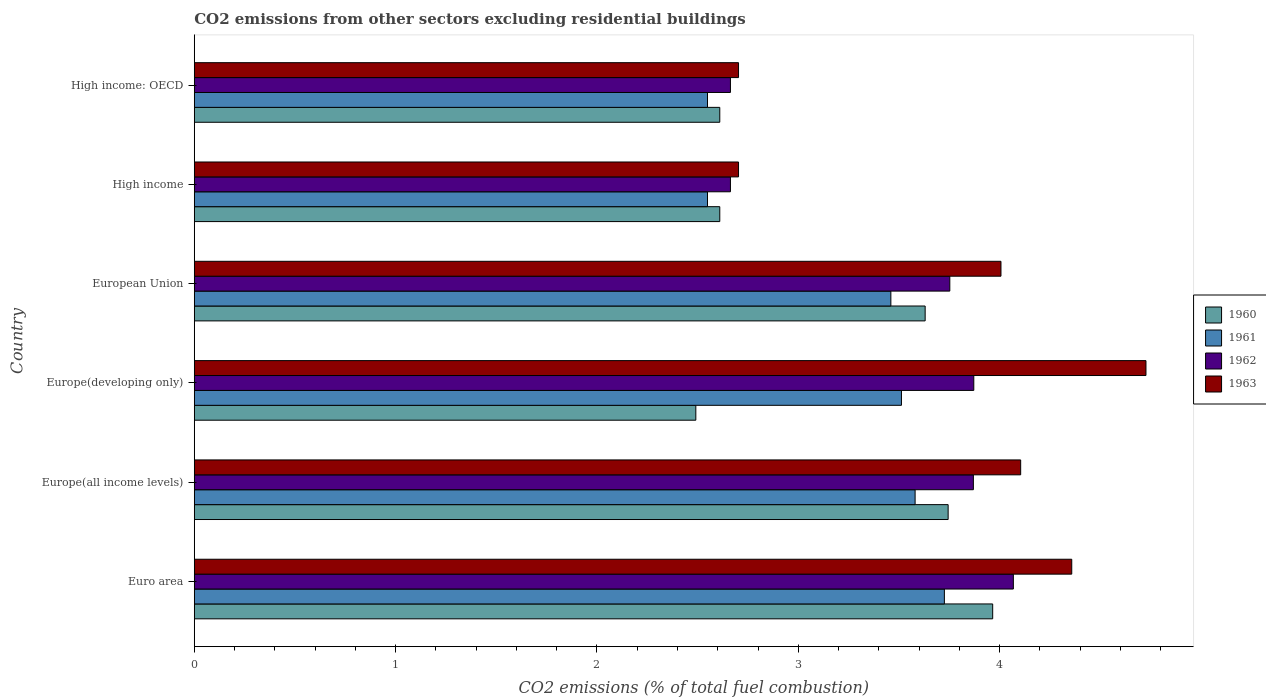How many different coloured bars are there?
Provide a succinct answer. 4. Are the number of bars on each tick of the Y-axis equal?
Keep it short and to the point. Yes. What is the total CO2 emitted in 1960 in Euro area?
Your answer should be very brief. 3.97. Across all countries, what is the maximum total CO2 emitted in 1962?
Make the answer very short. 4.07. Across all countries, what is the minimum total CO2 emitted in 1962?
Provide a short and direct response. 2.66. In which country was the total CO2 emitted in 1962 maximum?
Provide a short and direct response. Euro area. In which country was the total CO2 emitted in 1963 minimum?
Make the answer very short. High income. What is the total total CO2 emitted in 1962 in the graph?
Your answer should be compact. 20.89. What is the difference between the total CO2 emitted in 1962 in Europe(developing only) and that in High income: OECD?
Make the answer very short. 1.21. What is the difference between the total CO2 emitted in 1963 in Euro area and the total CO2 emitted in 1961 in Europe(developing only)?
Ensure brevity in your answer.  0.85. What is the average total CO2 emitted in 1962 per country?
Give a very brief answer. 3.48. What is the difference between the total CO2 emitted in 1960 and total CO2 emitted in 1961 in Europe(developing only)?
Provide a succinct answer. -1.02. In how many countries, is the total CO2 emitted in 1960 greater than 1.4 ?
Your answer should be very brief. 6. What is the ratio of the total CO2 emitted in 1962 in Europe(developing only) to that in High income: OECD?
Ensure brevity in your answer.  1.45. Is the difference between the total CO2 emitted in 1960 in Europe(all income levels) and High income: OECD greater than the difference between the total CO2 emitted in 1961 in Europe(all income levels) and High income: OECD?
Give a very brief answer. Yes. What is the difference between the highest and the second highest total CO2 emitted in 1961?
Ensure brevity in your answer.  0.15. What is the difference between the highest and the lowest total CO2 emitted in 1962?
Keep it short and to the point. 1.41. In how many countries, is the total CO2 emitted in 1962 greater than the average total CO2 emitted in 1962 taken over all countries?
Your answer should be compact. 4. Is the sum of the total CO2 emitted in 1963 in European Union and High income: OECD greater than the maximum total CO2 emitted in 1961 across all countries?
Your response must be concise. Yes. How many countries are there in the graph?
Your answer should be very brief. 6. What is the difference between two consecutive major ticks on the X-axis?
Provide a short and direct response. 1. How many legend labels are there?
Your answer should be very brief. 4. What is the title of the graph?
Ensure brevity in your answer.  CO2 emissions from other sectors excluding residential buildings. Does "1972" appear as one of the legend labels in the graph?
Make the answer very short. No. What is the label or title of the X-axis?
Your response must be concise. CO2 emissions (% of total fuel combustion). What is the CO2 emissions (% of total fuel combustion) in 1960 in Euro area?
Give a very brief answer. 3.97. What is the CO2 emissions (% of total fuel combustion) of 1961 in Euro area?
Your response must be concise. 3.73. What is the CO2 emissions (% of total fuel combustion) in 1962 in Euro area?
Your answer should be compact. 4.07. What is the CO2 emissions (% of total fuel combustion) in 1963 in Euro area?
Your response must be concise. 4.36. What is the CO2 emissions (% of total fuel combustion) of 1960 in Europe(all income levels)?
Provide a short and direct response. 3.74. What is the CO2 emissions (% of total fuel combustion) of 1961 in Europe(all income levels)?
Provide a short and direct response. 3.58. What is the CO2 emissions (% of total fuel combustion) of 1962 in Europe(all income levels)?
Give a very brief answer. 3.87. What is the CO2 emissions (% of total fuel combustion) in 1963 in Europe(all income levels)?
Provide a short and direct response. 4.1. What is the CO2 emissions (% of total fuel combustion) in 1960 in Europe(developing only)?
Your answer should be very brief. 2.49. What is the CO2 emissions (% of total fuel combustion) in 1961 in Europe(developing only)?
Offer a terse response. 3.51. What is the CO2 emissions (% of total fuel combustion) in 1962 in Europe(developing only)?
Provide a succinct answer. 3.87. What is the CO2 emissions (% of total fuel combustion) of 1963 in Europe(developing only)?
Keep it short and to the point. 4.73. What is the CO2 emissions (% of total fuel combustion) of 1960 in European Union?
Make the answer very short. 3.63. What is the CO2 emissions (% of total fuel combustion) in 1961 in European Union?
Offer a terse response. 3.46. What is the CO2 emissions (% of total fuel combustion) of 1962 in European Union?
Give a very brief answer. 3.75. What is the CO2 emissions (% of total fuel combustion) in 1963 in European Union?
Offer a terse response. 4.01. What is the CO2 emissions (% of total fuel combustion) in 1960 in High income?
Offer a terse response. 2.61. What is the CO2 emissions (% of total fuel combustion) in 1961 in High income?
Keep it short and to the point. 2.55. What is the CO2 emissions (% of total fuel combustion) of 1962 in High income?
Your answer should be compact. 2.66. What is the CO2 emissions (% of total fuel combustion) in 1963 in High income?
Ensure brevity in your answer.  2.7. What is the CO2 emissions (% of total fuel combustion) of 1960 in High income: OECD?
Keep it short and to the point. 2.61. What is the CO2 emissions (% of total fuel combustion) in 1961 in High income: OECD?
Keep it short and to the point. 2.55. What is the CO2 emissions (% of total fuel combustion) of 1962 in High income: OECD?
Your response must be concise. 2.66. What is the CO2 emissions (% of total fuel combustion) of 1963 in High income: OECD?
Offer a terse response. 2.7. Across all countries, what is the maximum CO2 emissions (% of total fuel combustion) in 1960?
Your response must be concise. 3.97. Across all countries, what is the maximum CO2 emissions (% of total fuel combustion) in 1961?
Make the answer very short. 3.73. Across all countries, what is the maximum CO2 emissions (% of total fuel combustion) in 1962?
Give a very brief answer. 4.07. Across all countries, what is the maximum CO2 emissions (% of total fuel combustion) of 1963?
Offer a very short reply. 4.73. Across all countries, what is the minimum CO2 emissions (% of total fuel combustion) of 1960?
Keep it short and to the point. 2.49. Across all countries, what is the minimum CO2 emissions (% of total fuel combustion) of 1961?
Your answer should be compact. 2.55. Across all countries, what is the minimum CO2 emissions (% of total fuel combustion) in 1962?
Offer a very short reply. 2.66. Across all countries, what is the minimum CO2 emissions (% of total fuel combustion) in 1963?
Offer a very short reply. 2.7. What is the total CO2 emissions (% of total fuel combustion) in 1960 in the graph?
Make the answer very short. 19.05. What is the total CO2 emissions (% of total fuel combustion) in 1961 in the graph?
Provide a short and direct response. 19.37. What is the total CO2 emissions (% of total fuel combustion) in 1962 in the graph?
Provide a succinct answer. 20.89. What is the total CO2 emissions (% of total fuel combustion) of 1963 in the graph?
Offer a terse response. 22.6. What is the difference between the CO2 emissions (% of total fuel combustion) in 1960 in Euro area and that in Europe(all income levels)?
Make the answer very short. 0.22. What is the difference between the CO2 emissions (% of total fuel combustion) in 1961 in Euro area and that in Europe(all income levels)?
Give a very brief answer. 0.15. What is the difference between the CO2 emissions (% of total fuel combustion) in 1962 in Euro area and that in Europe(all income levels)?
Offer a terse response. 0.2. What is the difference between the CO2 emissions (% of total fuel combustion) of 1963 in Euro area and that in Europe(all income levels)?
Offer a terse response. 0.25. What is the difference between the CO2 emissions (% of total fuel combustion) of 1960 in Euro area and that in Europe(developing only)?
Provide a succinct answer. 1.47. What is the difference between the CO2 emissions (% of total fuel combustion) of 1961 in Euro area and that in Europe(developing only)?
Your answer should be compact. 0.21. What is the difference between the CO2 emissions (% of total fuel combustion) in 1962 in Euro area and that in Europe(developing only)?
Provide a short and direct response. 0.2. What is the difference between the CO2 emissions (% of total fuel combustion) in 1963 in Euro area and that in Europe(developing only)?
Offer a terse response. -0.37. What is the difference between the CO2 emissions (% of total fuel combustion) in 1960 in Euro area and that in European Union?
Keep it short and to the point. 0.34. What is the difference between the CO2 emissions (% of total fuel combustion) of 1961 in Euro area and that in European Union?
Your answer should be very brief. 0.27. What is the difference between the CO2 emissions (% of total fuel combustion) in 1962 in Euro area and that in European Union?
Make the answer very short. 0.32. What is the difference between the CO2 emissions (% of total fuel combustion) in 1963 in Euro area and that in European Union?
Provide a short and direct response. 0.35. What is the difference between the CO2 emissions (% of total fuel combustion) in 1960 in Euro area and that in High income?
Give a very brief answer. 1.36. What is the difference between the CO2 emissions (% of total fuel combustion) in 1961 in Euro area and that in High income?
Your response must be concise. 1.18. What is the difference between the CO2 emissions (% of total fuel combustion) in 1962 in Euro area and that in High income?
Ensure brevity in your answer.  1.41. What is the difference between the CO2 emissions (% of total fuel combustion) in 1963 in Euro area and that in High income?
Your response must be concise. 1.65. What is the difference between the CO2 emissions (% of total fuel combustion) in 1960 in Euro area and that in High income: OECD?
Offer a terse response. 1.36. What is the difference between the CO2 emissions (% of total fuel combustion) of 1961 in Euro area and that in High income: OECD?
Your response must be concise. 1.18. What is the difference between the CO2 emissions (% of total fuel combustion) of 1962 in Euro area and that in High income: OECD?
Your answer should be compact. 1.41. What is the difference between the CO2 emissions (% of total fuel combustion) of 1963 in Euro area and that in High income: OECD?
Provide a succinct answer. 1.65. What is the difference between the CO2 emissions (% of total fuel combustion) in 1960 in Europe(all income levels) and that in Europe(developing only)?
Ensure brevity in your answer.  1.25. What is the difference between the CO2 emissions (% of total fuel combustion) of 1961 in Europe(all income levels) and that in Europe(developing only)?
Offer a very short reply. 0.07. What is the difference between the CO2 emissions (% of total fuel combustion) in 1962 in Europe(all income levels) and that in Europe(developing only)?
Ensure brevity in your answer.  -0. What is the difference between the CO2 emissions (% of total fuel combustion) in 1963 in Europe(all income levels) and that in Europe(developing only)?
Ensure brevity in your answer.  -0.62. What is the difference between the CO2 emissions (% of total fuel combustion) in 1960 in Europe(all income levels) and that in European Union?
Keep it short and to the point. 0.11. What is the difference between the CO2 emissions (% of total fuel combustion) of 1961 in Europe(all income levels) and that in European Union?
Provide a short and direct response. 0.12. What is the difference between the CO2 emissions (% of total fuel combustion) in 1962 in Europe(all income levels) and that in European Union?
Ensure brevity in your answer.  0.12. What is the difference between the CO2 emissions (% of total fuel combustion) in 1963 in Europe(all income levels) and that in European Union?
Provide a short and direct response. 0.1. What is the difference between the CO2 emissions (% of total fuel combustion) in 1960 in Europe(all income levels) and that in High income?
Offer a terse response. 1.13. What is the difference between the CO2 emissions (% of total fuel combustion) in 1961 in Europe(all income levels) and that in High income?
Your answer should be compact. 1.03. What is the difference between the CO2 emissions (% of total fuel combustion) of 1962 in Europe(all income levels) and that in High income?
Provide a short and direct response. 1.21. What is the difference between the CO2 emissions (% of total fuel combustion) of 1963 in Europe(all income levels) and that in High income?
Provide a succinct answer. 1.4. What is the difference between the CO2 emissions (% of total fuel combustion) of 1960 in Europe(all income levels) and that in High income: OECD?
Your response must be concise. 1.13. What is the difference between the CO2 emissions (% of total fuel combustion) of 1961 in Europe(all income levels) and that in High income: OECD?
Your response must be concise. 1.03. What is the difference between the CO2 emissions (% of total fuel combustion) of 1962 in Europe(all income levels) and that in High income: OECD?
Give a very brief answer. 1.21. What is the difference between the CO2 emissions (% of total fuel combustion) of 1963 in Europe(all income levels) and that in High income: OECD?
Give a very brief answer. 1.4. What is the difference between the CO2 emissions (% of total fuel combustion) in 1960 in Europe(developing only) and that in European Union?
Make the answer very short. -1.14. What is the difference between the CO2 emissions (% of total fuel combustion) of 1961 in Europe(developing only) and that in European Union?
Give a very brief answer. 0.05. What is the difference between the CO2 emissions (% of total fuel combustion) in 1962 in Europe(developing only) and that in European Union?
Offer a terse response. 0.12. What is the difference between the CO2 emissions (% of total fuel combustion) of 1963 in Europe(developing only) and that in European Union?
Your response must be concise. 0.72. What is the difference between the CO2 emissions (% of total fuel combustion) of 1960 in Europe(developing only) and that in High income?
Your response must be concise. -0.12. What is the difference between the CO2 emissions (% of total fuel combustion) in 1961 in Europe(developing only) and that in High income?
Offer a very short reply. 0.96. What is the difference between the CO2 emissions (% of total fuel combustion) of 1962 in Europe(developing only) and that in High income?
Your answer should be compact. 1.21. What is the difference between the CO2 emissions (% of total fuel combustion) of 1963 in Europe(developing only) and that in High income?
Keep it short and to the point. 2.02. What is the difference between the CO2 emissions (% of total fuel combustion) in 1960 in Europe(developing only) and that in High income: OECD?
Give a very brief answer. -0.12. What is the difference between the CO2 emissions (% of total fuel combustion) in 1961 in Europe(developing only) and that in High income: OECD?
Provide a succinct answer. 0.96. What is the difference between the CO2 emissions (% of total fuel combustion) of 1962 in Europe(developing only) and that in High income: OECD?
Give a very brief answer. 1.21. What is the difference between the CO2 emissions (% of total fuel combustion) of 1963 in Europe(developing only) and that in High income: OECD?
Your response must be concise. 2.02. What is the difference between the CO2 emissions (% of total fuel combustion) in 1960 in European Union and that in High income?
Make the answer very short. 1.02. What is the difference between the CO2 emissions (% of total fuel combustion) of 1961 in European Union and that in High income?
Keep it short and to the point. 0.91. What is the difference between the CO2 emissions (% of total fuel combustion) in 1962 in European Union and that in High income?
Ensure brevity in your answer.  1.09. What is the difference between the CO2 emissions (% of total fuel combustion) of 1963 in European Union and that in High income?
Ensure brevity in your answer.  1.3. What is the difference between the CO2 emissions (% of total fuel combustion) in 1961 in European Union and that in High income: OECD?
Offer a terse response. 0.91. What is the difference between the CO2 emissions (% of total fuel combustion) in 1962 in European Union and that in High income: OECD?
Provide a short and direct response. 1.09. What is the difference between the CO2 emissions (% of total fuel combustion) in 1963 in European Union and that in High income: OECD?
Your answer should be very brief. 1.3. What is the difference between the CO2 emissions (% of total fuel combustion) in 1960 in High income and that in High income: OECD?
Keep it short and to the point. 0. What is the difference between the CO2 emissions (% of total fuel combustion) of 1963 in High income and that in High income: OECD?
Make the answer very short. 0. What is the difference between the CO2 emissions (% of total fuel combustion) of 1960 in Euro area and the CO2 emissions (% of total fuel combustion) of 1961 in Europe(all income levels)?
Ensure brevity in your answer.  0.39. What is the difference between the CO2 emissions (% of total fuel combustion) of 1960 in Euro area and the CO2 emissions (% of total fuel combustion) of 1962 in Europe(all income levels)?
Make the answer very short. 0.1. What is the difference between the CO2 emissions (% of total fuel combustion) of 1960 in Euro area and the CO2 emissions (% of total fuel combustion) of 1963 in Europe(all income levels)?
Offer a terse response. -0.14. What is the difference between the CO2 emissions (% of total fuel combustion) in 1961 in Euro area and the CO2 emissions (% of total fuel combustion) in 1962 in Europe(all income levels)?
Give a very brief answer. -0.14. What is the difference between the CO2 emissions (% of total fuel combustion) of 1961 in Euro area and the CO2 emissions (% of total fuel combustion) of 1963 in Europe(all income levels)?
Make the answer very short. -0.38. What is the difference between the CO2 emissions (% of total fuel combustion) of 1962 in Euro area and the CO2 emissions (% of total fuel combustion) of 1963 in Europe(all income levels)?
Offer a terse response. -0.04. What is the difference between the CO2 emissions (% of total fuel combustion) in 1960 in Euro area and the CO2 emissions (% of total fuel combustion) in 1961 in Europe(developing only)?
Your answer should be very brief. 0.45. What is the difference between the CO2 emissions (% of total fuel combustion) of 1960 in Euro area and the CO2 emissions (% of total fuel combustion) of 1962 in Europe(developing only)?
Your answer should be very brief. 0.09. What is the difference between the CO2 emissions (% of total fuel combustion) in 1960 in Euro area and the CO2 emissions (% of total fuel combustion) in 1963 in Europe(developing only)?
Offer a very short reply. -0.76. What is the difference between the CO2 emissions (% of total fuel combustion) in 1961 in Euro area and the CO2 emissions (% of total fuel combustion) in 1962 in Europe(developing only)?
Provide a short and direct response. -0.15. What is the difference between the CO2 emissions (% of total fuel combustion) in 1961 in Euro area and the CO2 emissions (% of total fuel combustion) in 1963 in Europe(developing only)?
Make the answer very short. -1. What is the difference between the CO2 emissions (% of total fuel combustion) of 1962 in Euro area and the CO2 emissions (% of total fuel combustion) of 1963 in Europe(developing only)?
Ensure brevity in your answer.  -0.66. What is the difference between the CO2 emissions (% of total fuel combustion) in 1960 in Euro area and the CO2 emissions (% of total fuel combustion) in 1961 in European Union?
Provide a succinct answer. 0.51. What is the difference between the CO2 emissions (% of total fuel combustion) in 1960 in Euro area and the CO2 emissions (% of total fuel combustion) in 1962 in European Union?
Your response must be concise. 0.21. What is the difference between the CO2 emissions (% of total fuel combustion) of 1960 in Euro area and the CO2 emissions (% of total fuel combustion) of 1963 in European Union?
Provide a short and direct response. -0.04. What is the difference between the CO2 emissions (% of total fuel combustion) in 1961 in Euro area and the CO2 emissions (% of total fuel combustion) in 1962 in European Union?
Your answer should be very brief. -0.03. What is the difference between the CO2 emissions (% of total fuel combustion) of 1961 in Euro area and the CO2 emissions (% of total fuel combustion) of 1963 in European Union?
Provide a succinct answer. -0.28. What is the difference between the CO2 emissions (% of total fuel combustion) of 1962 in Euro area and the CO2 emissions (% of total fuel combustion) of 1963 in European Union?
Make the answer very short. 0.06. What is the difference between the CO2 emissions (% of total fuel combustion) in 1960 in Euro area and the CO2 emissions (% of total fuel combustion) in 1961 in High income?
Make the answer very short. 1.42. What is the difference between the CO2 emissions (% of total fuel combustion) in 1960 in Euro area and the CO2 emissions (% of total fuel combustion) in 1962 in High income?
Offer a terse response. 1.3. What is the difference between the CO2 emissions (% of total fuel combustion) of 1960 in Euro area and the CO2 emissions (% of total fuel combustion) of 1963 in High income?
Your answer should be compact. 1.26. What is the difference between the CO2 emissions (% of total fuel combustion) of 1961 in Euro area and the CO2 emissions (% of total fuel combustion) of 1963 in High income?
Your answer should be very brief. 1.02. What is the difference between the CO2 emissions (% of total fuel combustion) of 1962 in Euro area and the CO2 emissions (% of total fuel combustion) of 1963 in High income?
Make the answer very short. 1.36. What is the difference between the CO2 emissions (% of total fuel combustion) in 1960 in Euro area and the CO2 emissions (% of total fuel combustion) in 1961 in High income: OECD?
Your answer should be very brief. 1.42. What is the difference between the CO2 emissions (% of total fuel combustion) in 1960 in Euro area and the CO2 emissions (% of total fuel combustion) in 1962 in High income: OECD?
Your answer should be very brief. 1.3. What is the difference between the CO2 emissions (% of total fuel combustion) in 1960 in Euro area and the CO2 emissions (% of total fuel combustion) in 1963 in High income: OECD?
Make the answer very short. 1.26. What is the difference between the CO2 emissions (% of total fuel combustion) in 1961 in Euro area and the CO2 emissions (% of total fuel combustion) in 1962 in High income: OECD?
Give a very brief answer. 1.06. What is the difference between the CO2 emissions (% of total fuel combustion) in 1961 in Euro area and the CO2 emissions (% of total fuel combustion) in 1963 in High income: OECD?
Make the answer very short. 1.02. What is the difference between the CO2 emissions (% of total fuel combustion) of 1962 in Euro area and the CO2 emissions (% of total fuel combustion) of 1963 in High income: OECD?
Your response must be concise. 1.36. What is the difference between the CO2 emissions (% of total fuel combustion) of 1960 in Europe(all income levels) and the CO2 emissions (% of total fuel combustion) of 1961 in Europe(developing only)?
Give a very brief answer. 0.23. What is the difference between the CO2 emissions (% of total fuel combustion) in 1960 in Europe(all income levels) and the CO2 emissions (% of total fuel combustion) in 1962 in Europe(developing only)?
Provide a short and direct response. -0.13. What is the difference between the CO2 emissions (% of total fuel combustion) in 1960 in Europe(all income levels) and the CO2 emissions (% of total fuel combustion) in 1963 in Europe(developing only)?
Your answer should be very brief. -0.98. What is the difference between the CO2 emissions (% of total fuel combustion) of 1961 in Europe(all income levels) and the CO2 emissions (% of total fuel combustion) of 1962 in Europe(developing only)?
Provide a succinct answer. -0.29. What is the difference between the CO2 emissions (% of total fuel combustion) of 1961 in Europe(all income levels) and the CO2 emissions (% of total fuel combustion) of 1963 in Europe(developing only)?
Offer a terse response. -1.15. What is the difference between the CO2 emissions (% of total fuel combustion) in 1962 in Europe(all income levels) and the CO2 emissions (% of total fuel combustion) in 1963 in Europe(developing only)?
Your answer should be compact. -0.86. What is the difference between the CO2 emissions (% of total fuel combustion) in 1960 in Europe(all income levels) and the CO2 emissions (% of total fuel combustion) in 1961 in European Union?
Provide a succinct answer. 0.28. What is the difference between the CO2 emissions (% of total fuel combustion) in 1960 in Europe(all income levels) and the CO2 emissions (% of total fuel combustion) in 1962 in European Union?
Your answer should be compact. -0.01. What is the difference between the CO2 emissions (% of total fuel combustion) of 1960 in Europe(all income levels) and the CO2 emissions (% of total fuel combustion) of 1963 in European Union?
Offer a terse response. -0.26. What is the difference between the CO2 emissions (% of total fuel combustion) in 1961 in Europe(all income levels) and the CO2 emissions (% of total fuel combustion) in 1962 in European Union?
Ensure brevity in your answer.  -0.17. What is the difference between the CO2 emissions (% of total fuel combustion) in 1961 in Europe(all income levels) and the CO2 emissions (% of total fuel combustion) in 1963 in European Union?
Your answer should be compact. -0.43. What is the difference between the CO2 emissions (% of total fuel combustion) of 1962 in Europe(all income levels) and the CO2 emissions (% of total fuel combustion) of 1963 in European Union?
Make the answer very short. -0.14. What is the difference between the CO2 emissions (% of total fuel combustion) of 1960 in Europe(all income levels) and the CO2 emissions (% of total fuel combustion) of 1961 in High income?
Keep it short and to the point. 1.2. What is the difference between the CO2 emissions (% of total fuel combustion) of 1960 in Europe(all income levels) and the CO2 emissions (% of total fuel combustion) of 1962 in High income?
Provide a short and direct response. 1.08. What is the difference between the CO2 emissions (% of total fuel combustion) in 1960 in Europe(all income levels) and the CO2 emissions (% of total fuel combustion) in 1963 in High income?
Offer a terse response. 1.04. What is the difference between the CO2 emissions (% of total fuel combustion) in 1961 in Europe(all income levels) and the CO2 emissions (% of total fuel combustion) in 1962 in High income?
Your response must be concise. 0.92. What is the difference between the CO2 emissions (% of total fuel combustion) in 1961 in Europe(all income levels) and the CO2 emissions (% of total fuel combustion) in 1963 in High income?
Your answer should be very brief. 0.88. What is the difference between the CO2 emissions (% of total fuel combustion) in 1962 in Europe(all income levels) and the CO2 emissions (% of total fuel combustion) in 1963 in High income?
Give a very brief answer. 1.17. What is the difference between the CO2 emissions (% of total fuel combustion) in 1960 in Europe(all income levels) and the CO2 emissions (% of total fuel combustion) in 1961 in High income: OECD?
Keep it short and to the point. 1.2. What is the difference between the CO2 emissions (% of total fuel combustion) of 1960 in Europe(all income levels) and the CO2 emissions (% of total fuel combustion) of 1962 in High income: OECD?
Make the answer very short. 1.08. What is the difference between the CO2 emissions (% of total fuel combustion) of 1960 in Europe(all income levels) and the CO2 emissions (% of total fuel combustion) of 1963 in High income: OECD?
Make the answer very short. 1.04. What is the difference between the CO2 emissions (% of total fuel combustion) in 1961 in Europe(all income levels) and the CO2 emissions (% of total fuel combustion) in 1962 in High income: OECD?
Offer a terse response. 0.92. What is the difference between the CO2 emissions (% of total fuel combustion) in 1961 in Europe(all income levels) and the CO2 emissions (% of total fuel combustion) in 1963 in High income: OECD?
Offer a terse response. 0.88. What is the difference between the CO2 emissions (% of total fuel combustion) in 1962 in Europe(all income levels) and the CO2 emissions (% of total fuel combustion) in 1963 in High income: OECD?
Your response must be concise. 1.17. What is the difference between the CO2 emissions (% of total fuel combustion) of 1960 in Europe(developing only) and the CO2 emissions (% of total fuel combustion) of 1961 in European Union?
Keep it short and to the point. -0.97. What is the difference between the CO2 emissions (% of total fuel combustion) in 1960 in Europe(developing only) and the CO2 emissions (% of total fuel combustion) in 1962 in European Union?
Make the answer very short. -1.26. What is the difference between the CO2 emissions (% of total fuel combustion) in 1960 in Europe(developing only) and the CO2 emissions (% of total fuel combustion) in 1963 in European Union?
Provide a succinct answer. -1.52. What is the difference between the CO2 emissions (% of total fuel combustion) of 1961 in Europe(developing only) and the CO2 emissions (% of total fuel combustion) of 1962 in European Union?
Offer a terse response. -0.24. What is the difference between the CO2 emissions (% of total fuel combustion) in 1961 in Europe(developing only) and the CO2 emissions (% of total fuel combustion) in 1963 in European Union?
Keep it short and to the point. -0.49. What is the difference between the CO2 emissions (% of total fuel combustion) in 1962 in Europe(developing only) and the CO2 emissions (% of total fuel combustion) in 1963 in European Union?
Your answer should be very brief. -0.14. What is the difference between the CO2 emissions (% of total fuel combustion) in 1960 in Europe(developing only) and the CO2 emissions (% of total fuel combustion) in 1961 in High income?
Your response must be concise. -0.06. What is the difference between the CO2 emissions (% of total fuel combustion) in 1960 in Europe(developing only) and the CO2 emissions (% of total fuel combustion) in 1962 in High income?
Provide a short and direct response. -0.17. What is the difference between the CO2 emissions (% of total fuel combustion) of 1960 in Europe(developing only) and the CO2 emissions (% of total fuel combustion) of 1963 in High income?
Provide a succinct answer. -0.21. What is the difference between the CO2 emissions (% of total fuel combustion) of 1961 in Europe(developing only) and the CO2 emissions (% of total fuel combustion) of 1962 in High income?
Keep it short and to the point. 0.85. What is the difference between the CO2 emissions (% of total fuel combustion) in 1961 in Europe(developing only) and the CO2 emissions (% of total fuel combustion) in 1963 in High income?
Your answer should be compact. 0.81. What is the difference between the CO2 emissions (% of total fuel combustion) of 1962 in Europe(developing only) and the CO2 emissions (% of total fuel combustion) of 1963 in High income?
Offer a terse response. 1.17. What is the difference between the CO2 emissions (% of total fuel combustion) of 1960 in Europe(developing only) and the CO2 emissions (% of total fuel combustion) of 1961 in High income: OECD?
Your answer should be very brief. -0.06. What is the difference between the CO2 emissions (% of total fuel combustion) of 1960 in Europe(developing only) and the CO2 emissions (% of total fuel combustion) of 1962 in High income: OECD?
Your answer should be very brief. -0.17. What is the difference between the CO2 emissions (% of total fuel combustion) of 1960 in Europe(developing only) and the CO2 emissions (% of total fuel combustion) of 1963 in High income: OECD?
Keep it short and to the point. -0.21. What is the difference between the CO2 emissions (% of total fuel combustion) of 1961 in Europe(developing only) and the CO2 emissions (% of total fuel combustion) of 1962 in High income: OECD?
Give a very brief answer. 0.85. What is the difference between the CO2 emissions (% of total fuel combustion) of 1961 in Europe(developing only) and the CO2 emissions (% of total fuel combustion) of 1963 in High income: OECD?
Your response must be concise. 0.81. What is the difference between the CO2 emissions (% of total fuel combustion) in 1962 in Europe(developing only) and the CO2 emissions (% of total fuel combustion) in 1963 in High income: OECD?
Give a very brief answer. 1.17. What is the difference between the CO2 emissions (% of total fuel combustion) in 1960 in European Union and the CO2 emissions (% of total fuel combustion) in 1961 in High income?
Offer a terse response. 1.08. What is the difference between the CO2 emissions (% of total fuel combustion) of 1960 in European Union and the CO2 emissions (% of total fuel combustion) of 1962 in High income?
Provide a succinct answer. 0.97. What is the difference between the CO2 emissions (% of total fuel combustion) of 1960 in European Union and the CO2 emissions (% of total fuel combustion) of 1963 in High income?
Give a very brief answer. 0.93. What is the difference between the CO2 emissions (% of total fuel combustion) of 1961 in European Union and the CO2 emissions (% of total fuel combustion) of 1962 in High income?
Provide a short and direct response. 0.8. What is the difference between the CO2 emissions (% of total fuel combustion) of 1961 in European Union and the CO2 emissions (% of total fuel combustion) of 1963 in High income?
Make the answer very short. 0.76. What is the difference between the CO2 emissions (% of total fuel combustion) of 1962 in European Union and the CO2 emissions (% of total fuel combustion) of 1963 in High income?
Ensure brevity in your answer.  1.05. What is the difference between the CO2 emissions (% of total fuel combustion) in 1960 in European Union and the CO2 emissions (% of total fuel combustion) in 1961 in High income: OECD?
Offer a very short reply. 1.08. What is the difference between the CO2 emissions (% of total fuel combustion) of 1960 in European Union and the CO2 emissions (% of total fuel combustion) of 1963 in High income: OECD?
Ensure brevity in your answer.  0.93. What is the difference between the CO2 emissions (% of total fuel combustion) of 1961 in European Union and the CO2 emissions (% of total fuel combustion) of 1962 in High income: OECD?
Provide a short and direct response. 0.8. What is the difference between the CO2 emissions (% of total fuel combustion) in 1961 in European Union and the CO2 emissions (% of total fuel combustion) in 1963 in High income: OECD?
Provide a short and direct response. 0.76. What is the difference between the CO2 emissions (% of total fuel combustion) of 1962 in European Union and the CO2 emissions (% of total fuel combustion) of 1963 in High income: OECD?
Offer a terse response. 1.05. What is the difference between the CO2 emissions (% of total fuel combustion) in 1960 in High income and the CO2 emissions (% of total fuel combustion) in 1961 in High income: OECD?
Ensure brevity in your answer.  0.06. What is the difference between the CO2 emissions (% of total fuel combustion) in 1960 in High income and the CO2 emissions (% of total fuel combustion) in 1962 in High income: OECD?
Offer a terse response. -0.05. What is the difference between the CO2 emissions (% of total fuel combustion) of 1960 in High income and the CO2 emissions (% of total fuel combustion) of 1963 in High income: OECD?
Provide a succinct answer. -0.09. What is the difference between the CO2 emissions (% of total fuel combustion) of 1961 in High income and the CO2 emissions (% of total fuel combustion) of 1962 in High income: OECD?
Offer a very short reply. -0.11. What is the difference between the CO2 emissions (% of total fuel combustion) of 1961 in High income and the CO2 emissions (% of total fuel combustion) of 1963 in High income: OECD?
Keep it short and to the point. -0.15. What is the difference between the CO2 emissions (% of total fuel combustion) in 1962 in High income and the CO2 emissions (% of total fuel combustion) in 1963 in High income: OECD?
Provide a succinct answer. -0.04. What is the average CO2 emissions (% of total fuel combustion) in 1960 per country?
Provide a short and direct response. 3.17. What is the average CO2 emissions (% of total fuel combustion) in 1961 per country?
Make the answer very short. 3.23. What is the average CO2 emissions (% of total fuel combustion) of 1962 per country?
Your response must be concise. 3.48. What is the average CO2 emissions (% of total fuel combustion) of 1963 per country?
Give a very brief answer. 3.77. What is the difference between the CO2 emissions (% of total fuel combustion) of 1960 and CO2 emissions (% of total fuel combustion) of 1961 in Euro area?
Give a very brief answer. 0.24. What is the difference between the CO2 emissions (% of total fuel combustion) of 1960 and CO2 emissions (% of total fuel combustion) of 1962 in Euro area?
Your response must be concise. -0.1. What is the difference between the CO2 emissions (% of total fuel combustion) in 1960 and CO2 emissions (% of total fuel combustion) in 1963 in Euro area?
Your answer should be very brief. -0.39. What is the difference between the CO2 emissions (% of total fuel combustion) of 1961 and CO2 emissions (% of total fuel combustion) of 1962 in Euro area?
Make the answer very short. -0.34. What is the difference between the CO2 emissions (% of total fuel combustion) of 1961 and CO2 emissions (% of total fuel combustion) of 1963 in Euro area?
Your response must be concise. -0.63. What is the difference between the CO2 emissions (% of total fuel combustion) of 1962 and CO2 emissions (% of total fuel combustion) of 1963 in Euro area?
Provide a short and direct response. -0.29. What is the difference between the CO2 emissions (% of total fuel combustion) in 1960 and CO2 emissions (% of total fuel combustion) in 1961 in Europe(all income levels)?
Your response must be concise. 0.16. What is the difference between the CO2 emissions (% of total fuel combustion) of 1960 and CO2 emissions (% of total fuel combustion) of 1962 in Europe(all income levels)?
Make the answer very short. -0.13. What is the difference between the CO2 emissions (% of total fuel combustion) of 1960 and CO2 emissions (% of total fuel combustion) of 1963 in Europe(all income levels)?
Provide a short and direct response. -0.36. What is the difference between the CO2 emissions (% of total fuel combustion) of 1961 and CO2 emissions (% of total fuel combustion) of 1962 in Europe(all income levels)?
Give a very brief answer. -0.29. What is the difference between the CO2 emissions (% of total fuel combustion) in 1961 and CO2 emissions (% of total fuel combustion) in 1963 in Europe(all income levels)?
Your response must be concise. -0.52. What is the difference between the CO2 emissions (% of total fuel combustion) in 1962 and CO2 emissions (% of total fuel combustion) in 1963 in Europe(all income levels)?
Give a very brief answer. -0.23. What is the difference between the CO2 emissions (% of total fuel combustion) in 1960 and CO2 emissions (% of total fuel combustion) in 1961 in Europe(developing only)?
Offer a very short reply. -1.02. What is the difference between the CO2 emissions (% of total fuel combustion) of 1960 and CO2 emissions (% of total fuel combustion) of 1962 in Europe(developing only)?
Offer a terse response. -1.38. What is the difference between the CO2 emissions (% of total fuel combustion) in 1960 and CO2 emissions (% of total fuel combustion) in 1963 in Europe(developing only)?
Your response must be concise. -2.24. What is the difference between the CO2 emissions (% of total fuel combustion) in 1961 and CO2 emissions (% of total fuel combustion) in 1962 in Europe(developing only)?
Make the answer very short. -0.36. What is the difference between the CO2 emissions (% of total fuel combustion) of 1961 and CO2 emissions (% of total fuel combustion) of 1963 in Europe(developing only)?
Provide a succinct answer. -1.21. What is the difference between the CO2 emissions (% of total fuel combustion) of 1962 and CO2 emissions (% of total fuel combustion) of 1963 in Europe(developing only)?
Your answer should be compact. -0.85. What is the difference between the CO2 emissions (% of total fuel combustion) of 1960 and CO2 emissions (% of total fuel combustion) of 1961 in European Union?
Your answer should be compact. 0.17. What is the difference between the CO2 emissions (% of total fuel combustion) in 1960 and CO2 emissions (% of total fuel combustion) in 1962 in European Union?
Offer a very short reply. -0.12. What is the difference between the CO2 emissions (% of total fuel combustion) of 1960 and CO2 emissions (% of total fuel combustion) of 1963 in European Union?
Provide a short and direct response. -0.38. What is the difference between the CO2 emissions (% of total fuel combustion) of 1961 and CO2 emissions (% of total fuel combustion) of 1962 in European Union?
Make the answer very short. -0.29. What is the difference between the CO2 emissions (% of total fuel combustion) in 1961 and CO2 emissions (% of total fuel combustion) in 1963 in European Union?
Offer a very short reply. -0.55. What is the difference between the CO2 emissions (% of total fuel combustion) of 1962 and CO2 emissions (% of total fuel combustion) of 1963 in European Union?
Keep it short and to the point. -0.25. What is the difference between the CO2 emissions (% of total fuel combustion) of 1960 and CO2 emissions (% of total fuel combustion) of 1961 in High income?
Give a very brief answer. 0.06. What is the difference between the CO2 emissions (% of total fuel combustion) in 1960 and CO2 emissions (% of total fuel combustion) in 1962 in High income?
Your answer should be compact. -0.05. What is the difference between the CO2 emissions (% of total fuel combustion) in 1960 and CO2 emissions (% of total fuel combustion) in 1963 in High income?
Your answer should be very brief. -0.09. What is the difference between the CO2 emissions (% of total fuel combustion) of 1961 and CO2 emissions (% of total fuel combustion) of 1962 in High income?
Offer a terse response. -0.11. What is the difference between the CO2 emissions (% of total fuel combustion) of 1961 and CO2 emissions (% of total fuel combustion) of 1963 in High income?
Your response must be concise. -0.15. What is the difference between the CO2 emissions (% of total fuel combustion) in 1962 and CO2 emissions (% of total fuel combustion) in 1963 in High income?
Provide a succinct answer. -0.04. What is the difference between the CO2 emissions (% of total fuel combustion) in 1960 and CO2 emissions (% of total fuel combustion) in 1961 in High income: OECD?
Keep it short and to the point. 0.06. What is the difference between the CO2 emissions (% of total fuel combustion) of 1960 and CO2 emissions (% of total fuel combustion) of 1962 in High income: OECD?
Provide a succinct answer. -0.05. What is the difference between the CO2 emissions (% of total fuel combustion) of 1960 and CO2 emissions (% of total fuel combustion) of 1963 in High income: OECD?
Your answer should be very brief. -0.09. What is the difference between the CO2 emissions (% of total fuel combustion) of 1961 and CO2 emissions (% of total fuel combustion) of 1962 in High income: OECD?
Ensure brevity in your answer.  -0.11. What is the difference between the CO2 emissions (% of total fuel combustion) of 1961 and CO2 emissions (% of total fuel combustion) of 1963 in High income: OECD?
Offer a terse response. -0.15. What is the difference between the CO2 emissions (% of total fuel combustion) in 1962 and CO2 emissions (% of total fuel combustion) in 1963 in High income: OECD?
Provide a short and direct response. -0.04. What is the ratio of the CO2 emissions (% of total fuel combustion) of 1960 in Euro area to that in Europe(all income levels)?
Provide a short and direct response. 1.06. What is the ratio of the CO2 emissions (% of total fuel combustion) of 1961 in Euro area to that in Europe(all income levels)?
Offer a very short reply. 1.04. What is the ratio of the CO2 emissions (% of total fuel combustion) of 1962 in Euro area to that in Europe(all income levels)?
Make the answer very short. 1.05. What is the ratio of the CO2 emissions (% of total fuel combustion) in 1963 in Euro area to that in Europe(all income levels)?
Make the answer very short. 1.06. What is the ratio of the CO2 emissions (% of total fuel combustion) of 1960 in Euro area to that in Europe(developing only)?
Keep it short and to the point. 1.59. What is the ratio of the CO2 emissions (% of total fuel combustion) of 1961 in Euro area to that in Europe(developing only)?
Provide a short and direct response. 1.06. What is the ratio of the CO2 emissions (% of total fuel combustion) of 1962 in Euro area to that in Europe(developing only)?
Keep it short and to the point. 1.05. What is the ratio of the CO2 emissions (% of total fuel combustion) of 1963 in Euro area to that in Europe(developing only)?
Ensure brevity in your answer.  0.92. What is the ratio of the CO2 emissions (% of total fuel combustion) of 1960 in Euro area to that in European Union?
Provide a succinct answer. 1.09. What is the ratio of the CO2 emissions (% of total fuel combustion) of 1961 in Euro area to that in European Union?
Provide a short and direct response. 1.08. What is the ratio of the CO2 emissions (% of total fuel combustion) of 1962 in Euro area to that in European Union?
Offer a very short reply. 1.08. What is the ratio of the CO2 emissions (% of total fuel combustion) in 1963 in Euro area to that in European Union?
Your response must be concise. 1.09. What is the ratio of the CO2 emissions (% of total fuel combustion) in 1960 in Euro area to that in High income?
Ensure brevity in your answer.  1.52. What is the ratio of the CO2 emissions (% of total fuel combustion) of 1961 in Euro area to that in High income?
Give a very brief answer. 1.46. What is the ratio of the CO2 emissions (% of total fuel combustion) of 1962 in Euro area to that in High income?
Your answer should be compact. 1.53. What is the ratio of the CO2 emissions (% of total fuel combustion) of 1963 in Euro area to that in High income?
Your answer should be very brief. 1.61. What is the ratio of the CO2 emissions (% of total fuel combustion) in 1960 in Euro area to that in High income: OECD?
Make the answer very short. 1.52. What is the ratio of the CO2 emissions (% of total fuel combustion) of 1961 in Euro area to that in High income: OECD?
Ensure brevity in your answer.  1.46. What is the ratio of the CO2 emissions (% of total fuel combustion) in 1962 in Euro area to that in High income: OECD?
Your answer should be compact. 1.53. What is the ratio of the CO2 emissions (% of total fuel combustion) in 1963 in Euro area to that in High income: OECD?
Offer a very short reply. 1.61. What is the ratio of the CO2 emissions (% of total fuel combustion) of 1960 in Europe(all income levels) to that in Europe(developing only)?
Provide a succinct answer. 1.5. What is the ratio of the CO2 emissions (% of total fuel combustion) in 1961 in Europe(all income levels) to that in Europe(developing only)?
Your answer should be compact. 1.02. What is the ratio of the CO2 emissions (% of total fuel combustion) of 1962 in Europe(all income levels) to that in Europe(developing only)?
Your answer should be compact. 1. What is the ratio of the CO2 emissions (% of total fuel combustion) in 1963 in Europe(all income levels) to that in Europe(developing only)?
Provide a short and direct response. 0.87. What is the ratio of the CO2 emissions (% of total fuel combustion) of 1960 in Europe(all income levels) to that in European Union?
Offer a very short reply. 1.03. What is the ratio of the CO2 emissions (% of total fuel combustion) in 1961 in Europe(all income levels) to that in European Union?
Provide a succinct answer. 1.03. What is the ratio of the CO2 emissions (% of total fuel combustion) of 1962 in Europe(all income levels) to that in European Union?
Ensure brevity in your answer.  1.03. What is the ratio of the CO2 emissions (% of total fuel combustion) in 1963 in Europe(all income levels) to that in European Union?
Your answer should be very brief. 1.02. What is the ratio of the CO2 emissions (% of total fuel combustion) in 1960 in Europe(all income levels) to that in High income?
Your answer should be compact. 1.43. What is the ratio of the CO2 emissions (% of total fuel combustion) of 1961 in Europe(all income levels) to that in High income?
Give a very brief answer. 1.4. What is the ratio of the CO2 emissions (% of total fuel combustion) of 1962 in Europe(all income levels) to that in High income?
Make the answer very short. 1.45. What is the ratio of the CO2 emissions (% of total fuel combustion) in 1963 in Europe(all income levels) to that in High income?
Give a very brief answer. 1.52. What is the ratio of the CO2 emissions (% of total fuel combustion) of 1960 in Europe(all income levels) to that in High income: OECD?
Offer a terse response. 1.43. What is the ratio of the CO2 emissions (% of total fuel combustion) of 1961 in Europe(all income levels) to that in High income: OECD?
Keep it short and to the point. 1.4. What is the ratio of the CO2 emissions (% of total fuel combustion) in 1962 in Europe(all income levels) to that in High income: OECD?
Offer a terse response. 1.45. What is the ratio of the CO2 emissions (% of total fuel combustion) in 1963 in Europe(all income levels) to that in High income: OECD?
Offer a very short reply. 1.52. What is the ratio of the CO2 emissions (% of total fuel combustion) in 1960 in Europe(developing only) to that in European Union?
Keep it short and to the point. 0.69. What is the ratio of the CO2 emissions (% of total fuel combustion) of 1961 in Europe(developing only) to that in European Union?
Your answer should be very brief. 1.02. What is the ratio of the CO2 emissions (% of total fuel combustion) of 1962 in Europe(developing only) to that in European Union?
Provide a short and direct response. 1.03. What is the ratio of the CO2 emissions (% of total fuel combustion) in 1963 in Europe(developing only) to that in European Union?
Your answer should be very brief. 1.18. What is the ratio of the CO2 emissions (% of total fuel combustion) of 1960 in Europe(developing only) to that in High income?
Ensure brevity in your answer.  0.95. What is the ratio of the CO2 emissions (% of total fuel combustion) in 1961 in Europe(developing only) to that in High income?
Give a very brief answer. 1.38. What is the ratio of the CO2 emissions (% of total fuel combustion) of 1962 in Europe(developing only) to that in High income?
Your response must be concise. 1.45. What is the ratio of the CO2 emissions (% of total fuel combustion) in 1963 in Europe(developing only) to that in High income?
Your answer should be compact. 1.75. What is the ratio of the CO2 emissions (% of total fuel combustion) of 1960 in Europe(developing only) to that in High income: OECD?
Offer a terse response. 0.95. What is the ratio of the CO2 emissions (% of total fuel combustion) of 1961 in Europe(developing only) to that in High income: OECD?
Provide a succinct answer. 1.38. What is the ratio of the CO2 emissions (% of total fuel combustion) of 1962 in Europe(developing only) to that in High income: OECD?
Your answer should be very brief. 1.45. What is the ratio of the CO2 emissions (% of total fuel combustion) of 1963 in Europe(developing only) to that in High income: OECD?
Provide a succinct answer. 1.75. What is the ratio of the CO2 emissions (% of total fuel combustion) in 1960 in European Union to that in High income?
Your response must be concise. 1.39. What is the ratio of the CO2 emissions (% of total fuel combustion) in 1961 in European Union to that in High income?
Offer a terse response. 1.36. What is the ratio of the CO2 emissions (% of total fuel combustion) of 1962 in European Union to that in High income?
Offer a very short reply. 1.41. What is the ratio of the CO2 emissions (% of total fuel combustion) in 1963 in European Union to that in High income?
Your answer should be very brief. 1.48. What is the ratio of the CO2 emissions (% of total fuel combustion) in 1960 in European Union to that in High income: OECD?
Provide a short and direct response. 1.39. What is the ratio of the CO2 emissions (% of total fuel combustion) in 1961 in European Union to that in High income: OECD?
Keep it short and to the point. 1.36. What is the ratio of the CO2 emissions (% of total fuel combustion) in 1962 in European Union to that in High income: OECD?
Give a very brief answer. 1.41. What is the ratio of the CO2 emissions (% of total fuel combustion) in 1963 in European Union to that in High income: OECD?
Your answer should be very brief. 1.48. What is the ratio of the CO2 emissions (% of total fuel combustion) in 1963 in High income to that in High income: OECD?
Make the answer very short. 1. What is the difference between the highest and the second highest CO2 emissions (% of total fuel combustion) in 1960?
Your answer should be compact. 0.22. What is the difference between the highest and the second highest CO2 emissions (% of total fuel combustion) in 1961?
Offer a terse response. 0.15. What is the difference between the highest and the second highest CO2 emissions (% of total fuel combustion) in 1962?
Your answer should be very brief. 0.2. What is the difference between the highest and the second highest CO2 emissions (% of total fuel combustion) in 1963?
Give a very brief answer. 0.37. What is the difference between the highest and the lowest CO2 emissions (% of total fuel combustion) in 1960?
Provide a succinct answer. 1.47. What is the difference between the highest and the lowest CO2 emissions (% of total fuel combustion) of 1961?
Keep it short and to the point. 1.18. What is the difference between the highest and the lowest CO2 emissions (% of total fuel combustion) of 1962?
Your answer should be very brief. 1.41. What is the difference between the highest and the lowest CO2 emissions (% of total fuel combustion) of 1963?
Ensure brevity in your answer.  2.02. 